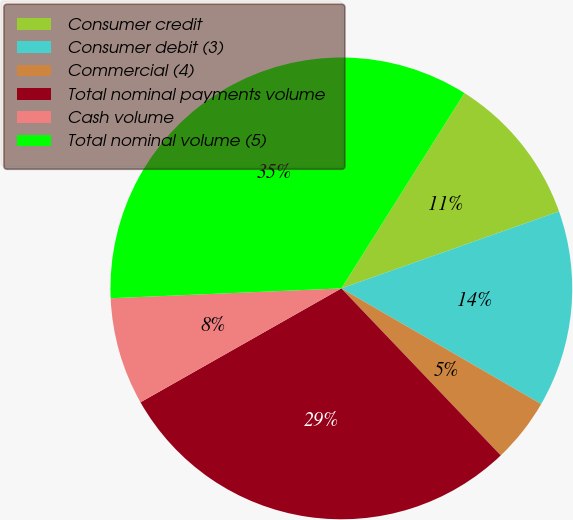Convert chart. <chart><loc_0><loc_0><loc_500><loc_500><pie_chart><fcel>Consumer credit<fcel>Consumer debit (3)<fcel>Commercial (4)<fcel>Total nominal payments volume<fcel>Cash volume<fcel>Total nominal volume (5)<nl><fcel>10.64%<fcel>13.76%<fcel>4.52%<fcel>28.92%<fcel>7.53%<fcel>34.63%<nl></chart> 